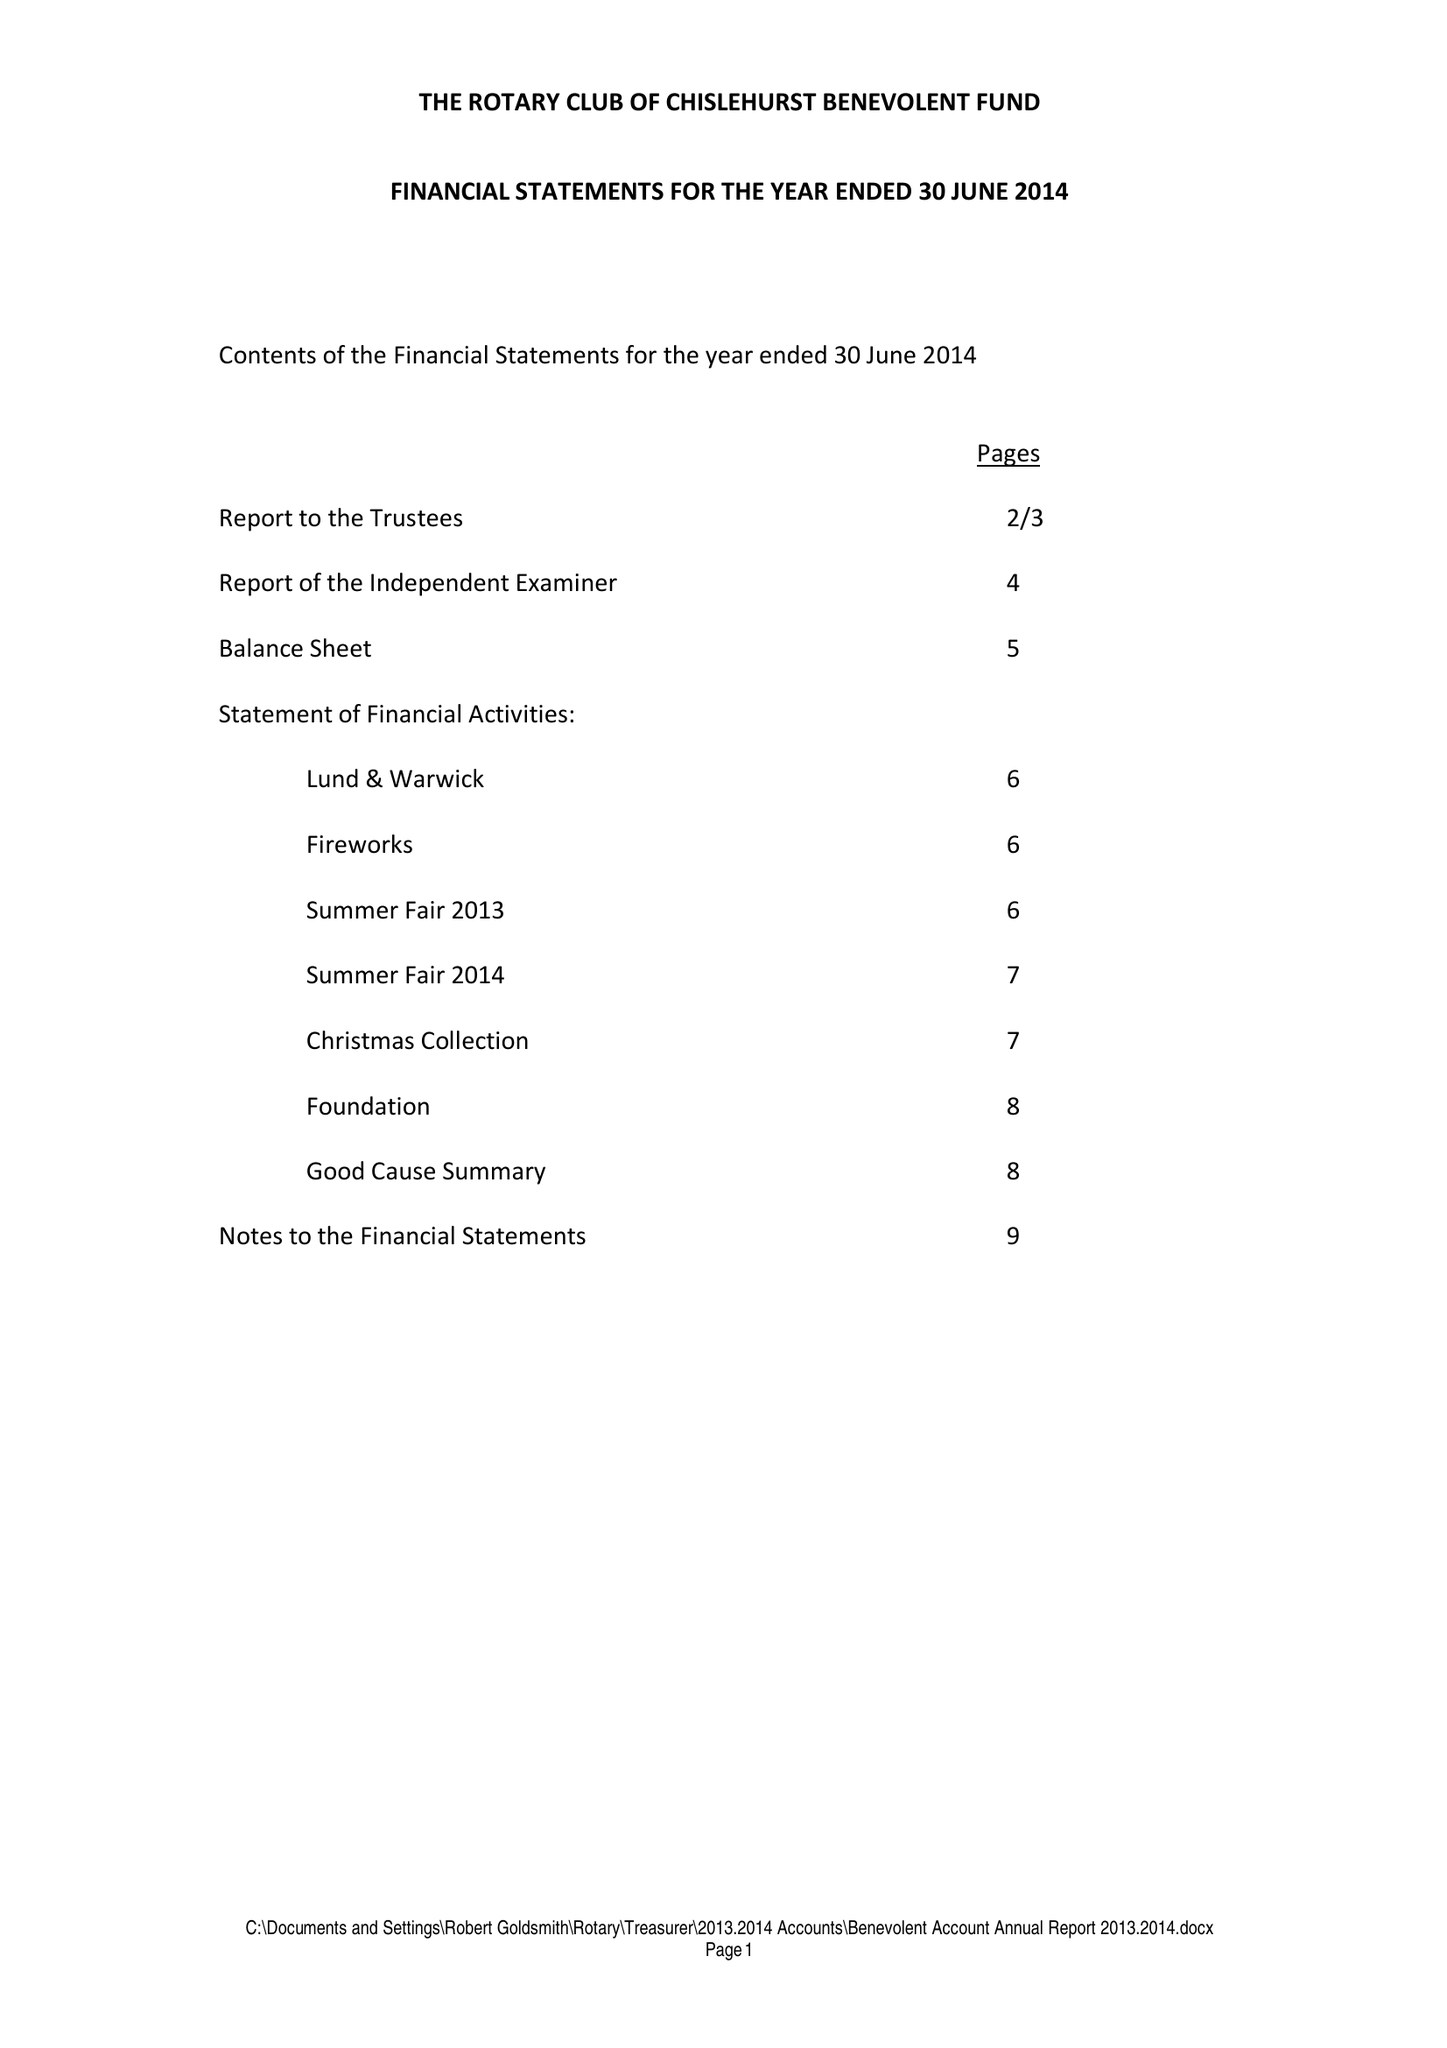What is the value for the address__post_town?
Answer the question using a single word or phrase. ORPINGTON 